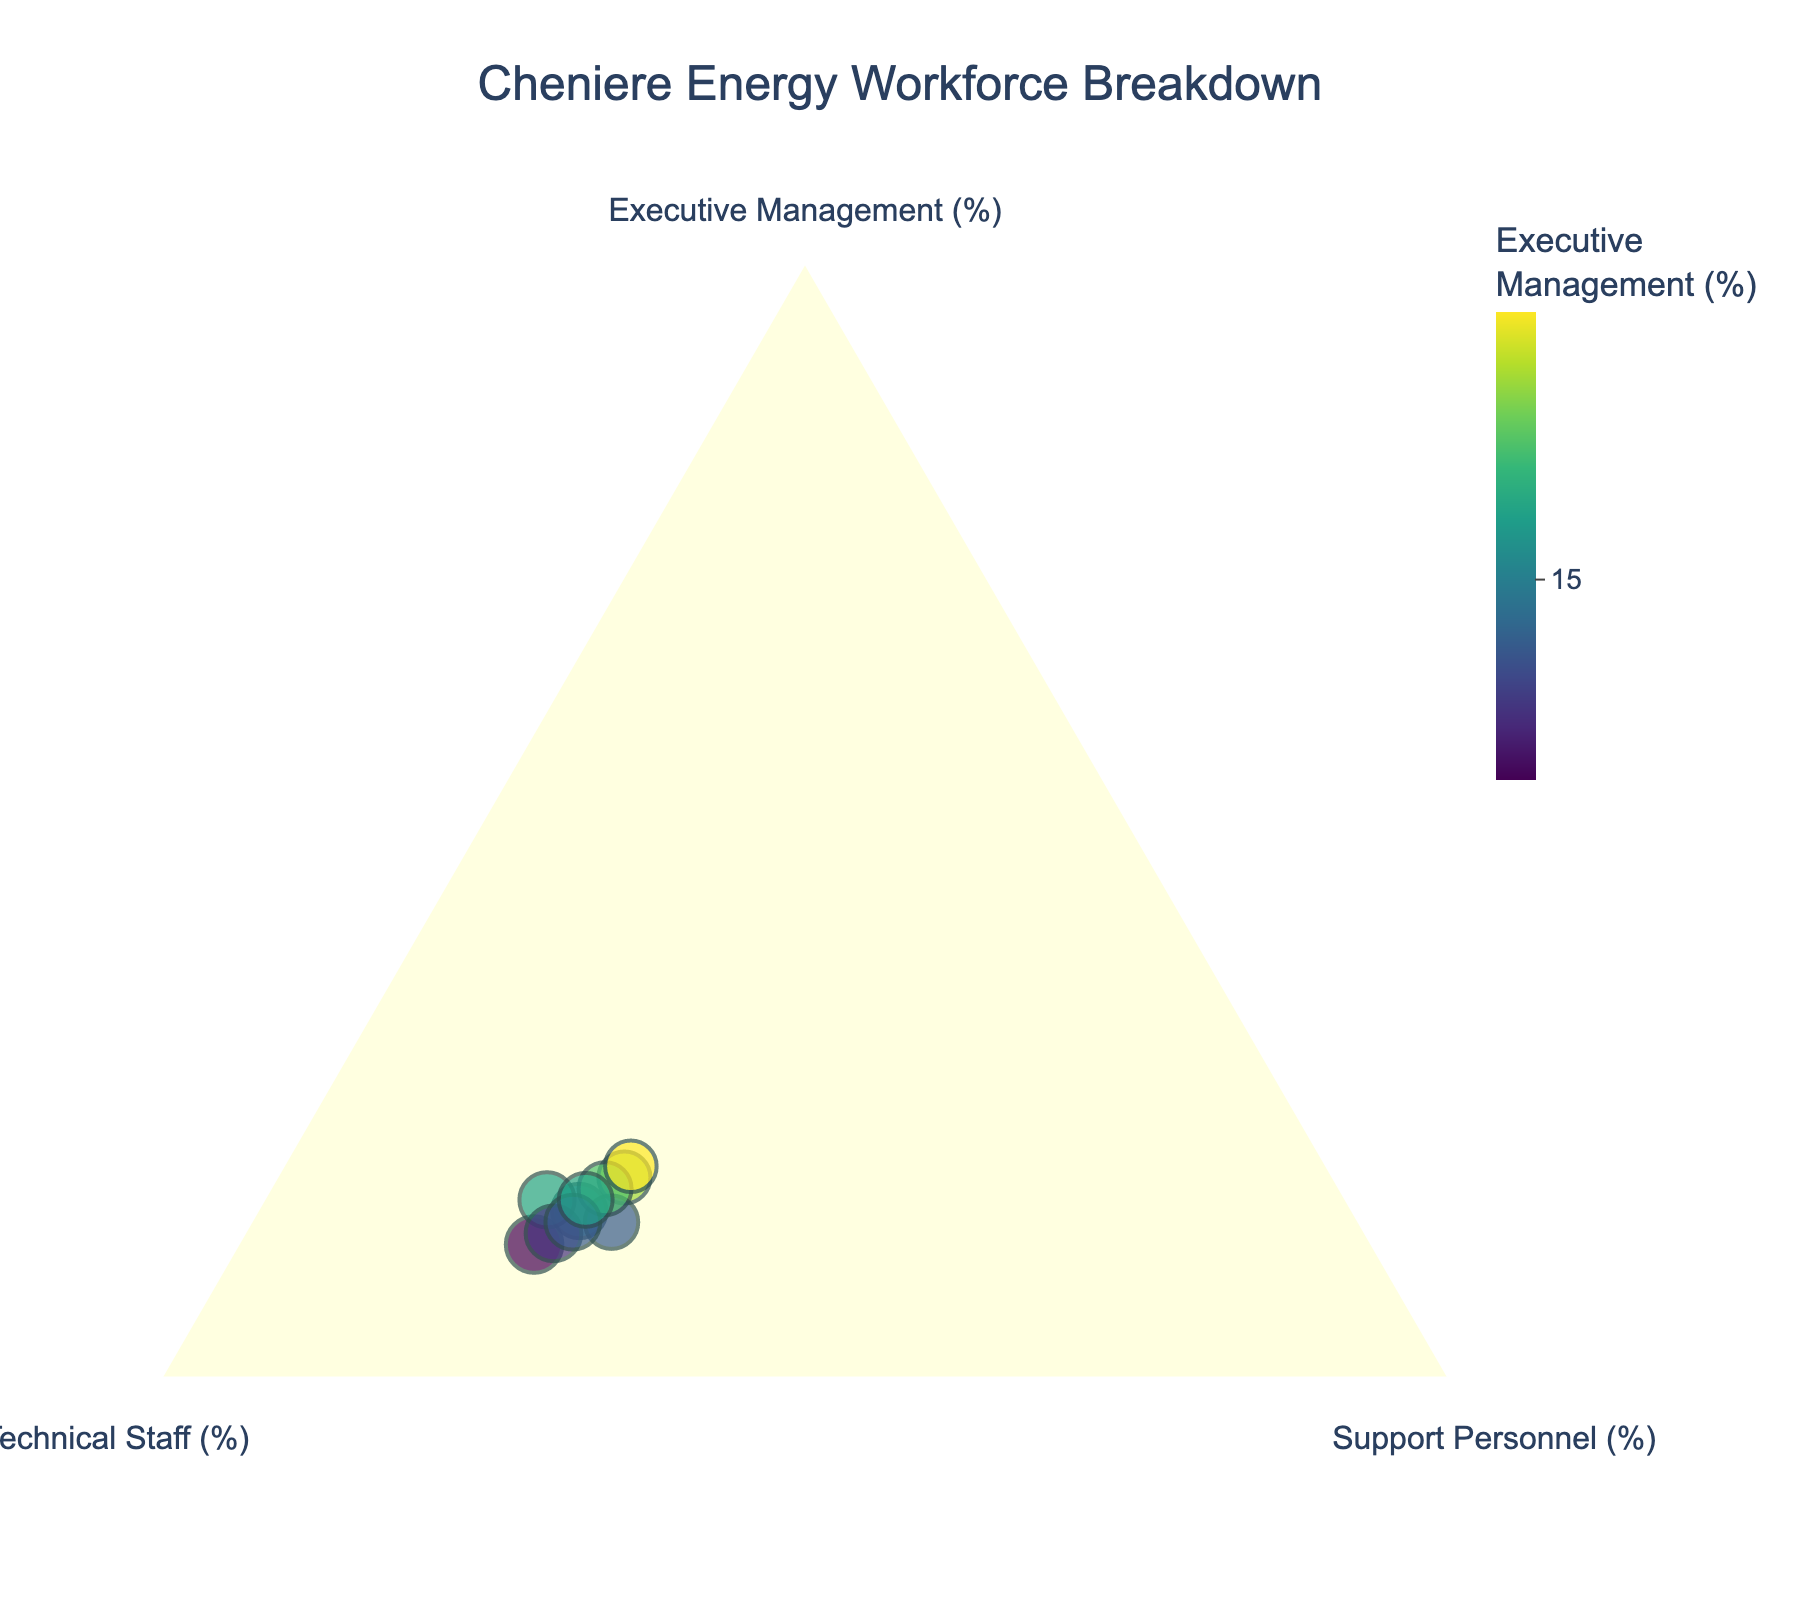What is the title of the ternary plot? The title of the ternary plot is displayed at the top center of the figure.
Answer: Cheniere Energy Workforce Breakdown How many data points are plotted on the ternary plot? Simply count the number of points visible on the ternary plot.
Answer: 10 What is the range of the 'Technical Staff (%)' axis as shown in the plot? The 'Technical Staff (%)' axis range is indicated by the ticks shown on the axis.
Answer: 50 to 70 Which data point has the highest percentage of Executive Management? Determine the data point with the highest value in the 'Executive Management (%)' axis.
Answer: 19% What is the average percentage of Support Personnel across all data points? Sum all the percentages of Support Personnel and divide by the number of data points. (25 + 23 + 27 + 28 + 22 + 24 + 26 + 27 + 25 + 25) / 10 = 25.2
Answer: 25.2% Which point has the lowest percentage of Technical Staff? Identify the point with the minimum value in the 'Technical Staff (%)' axis.
Answer: 54% Are there any data points where the percentage of Technical Staff is greater than 60%? Check each point for values of Technical Staff (%) greater than 60. Many points have Technical Staff percentages greater than 60%.
Answer: Yes How does the median value of Executive Management compare to the median value of Support Personnel? Arrange the percentages of Executive Management and Support Personnel in ascending order and find the middle value for each. Compare these two values. Executive Management: 12, 13, 14, 14, 15, 16, 16, 17, 18, 19 (median: 15.5); Support Personnel: 22, 23, 24, 25, 25, 25, 26, 27, 27, 28 (median: 25).
Answer: The median value of Support Personnel is higher (25 vs. 15.5%) What is the general trend observed between the variables Executive Management, Technical Staff, and Support Personnel? Since it's a ternary plot, generally when one category increases, another decreases. Identify patterns in the data points' positions. Most points show that if Executive Management increases, there is a tendency for Technical Staff to decrease and vice versa.
Answer: Inverse relationship between Executive Management and Technical Staff Which axis has the maximum spread of data points in the ternary plot? Compare the range of values (max - min) in each axis. Technical Staff ranges from 54 to 65, Support Personnel ranges from 22 to 28, Executive Management ranges from 12 to 19.
Answer: Technical Staff axis 